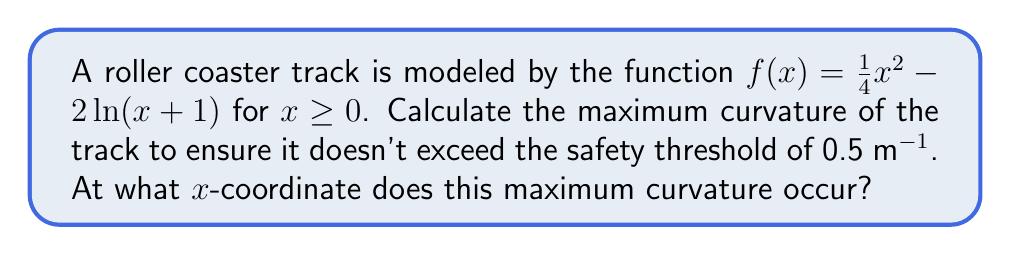Could you help me with this problem? Let's approach this step-by-step:

1) The curvature of a function $y = f(x)$ is given by the formula:

   $$\kappa = \frac{|f''(x)|}{(1 + (f'(x))^2)^{3/2}}$$

2) We need to find $f'(x)$ and $f''(x)$:
   
   $$f'(x) = \frac{1}{2}x - \frac{2}{x+1}$$
   
   $$f''(x) = \frac{1}{2} + \frac{2}{(x+1)^2}$$

3) Substituting these into the curvature formula:

   $$\kappa = \frac{|\frac{1}{2} + \frac{2}{(x+1)^2}|}{(1 + (\frac{1}{2}x - \frac{2}{x+1})^2)^{3/2}}$$

4) To find the maximum curvature, we need to find where $\frac{d\kappa}{dx} = 0$. However, this leads to a complex equation. Instead, we can observe that the numerator is always positive, so the maximum curvature will occur where the numerator is largest and the denominator is smallest.

5) The numerator is largest when x is smallest (i.e., when x approaches 0). The denominator is smallest when $f'(x) = 0$.

6) Let's solve $f'(x) = 0$:

   $$\frac{1}{2}x - \frac{2}{x+1} = 0$$
   $$\frac{1}{2}x(x+1) = 2$$
   $$\frac{1}{2}(x^2 + x) = 2$$
   $$x^2 + x - 4 = 0$$

7) Solving this quadratic equation:

   $$x = \frac{-1 \pm \sqrt{1^2 - 4(1)(-4)}}{2(1)} = \frac{-1 \pm \sqrt{17}}{2}$$

   We take the positive solution: $x = \frac{-1 + \sqrt{17}}{2} \approx 1.56$

8) Now we can calculate the maximum curvature:

   $$\kappa_{max} = \frac{|\frac{1}{2} + \frac{2}{(1.56+1)^2}|}{(1 + (0)^2)^{3/2}} \approx 0.4951 \text{ m}^{-1}$$

9) This is just below the safety threshold of 0.5 m^(-1).
Answer: Maximum curvature ≈ 0.4951 m^(-1) at x ≈ 1.56 